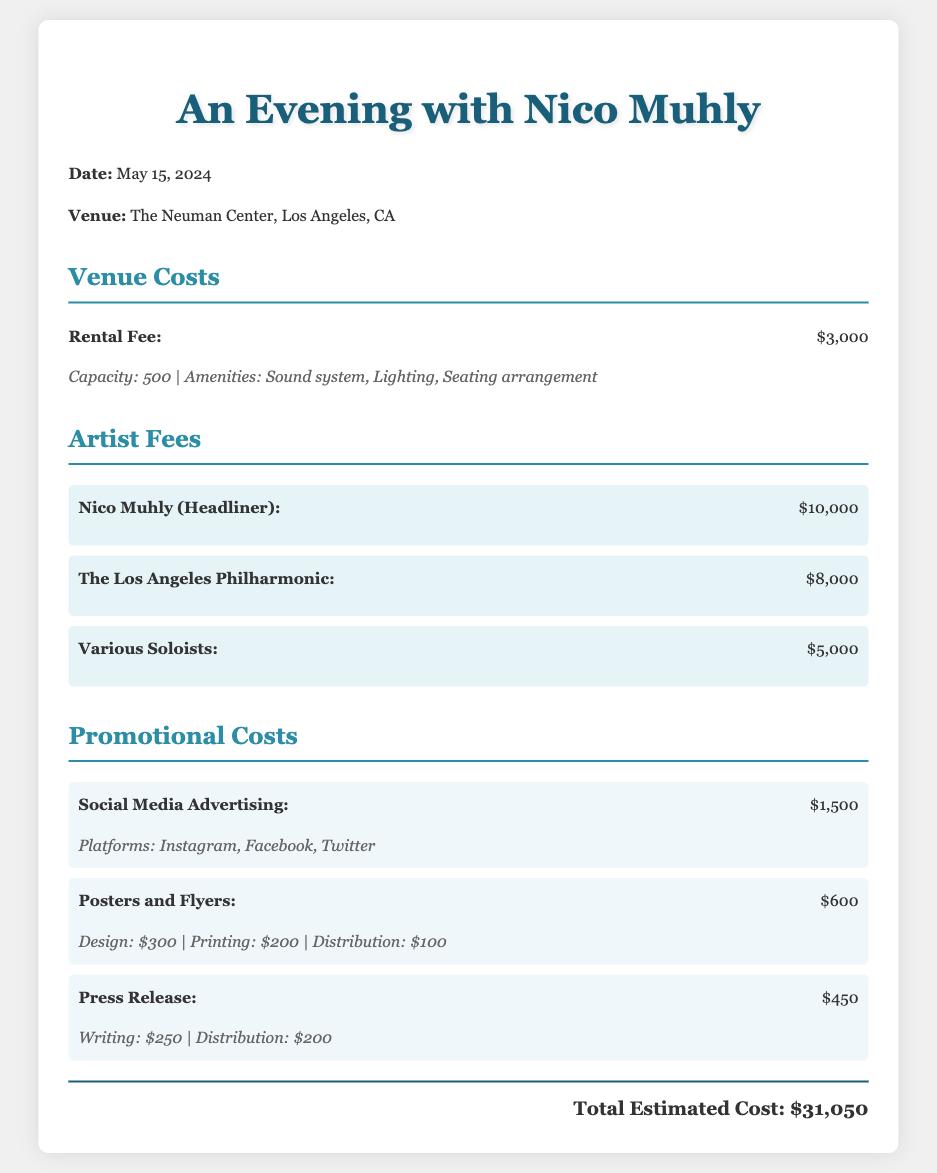What is the date of the concert? The date of the concert is specified in the document, which is May 15, 2024.
Answer: May 15, 2024 What is the total estimated cost? The total estimated cost is stated in the document, which sums up all the expenses listed.
Answer: $31,050 What is the rental fee for the venue? The rental fee for the venue is explicitly mentioned in the budget section as $3,000.
Answer: $3,000 How much is Nico Muhly's artist fee? The artist fee for Nico Muhly is listed as the headliner fee in the document, which is $10,000.
Answer: $10,000 What is the cost for social media advertising? The cost for social media advertising is specifically indicated in the document as $1,500.
Answer: $1,500 How much do the various soloists cost? The cost for various soloists is detailed in the artist fees section, stated as $5,000.
Answer: $5,000 Which platforms are included in the social media advertising? The platforms used for advertising are mentioned in the promotional costs section of the document.
Answer: Instagram, Facebook, Twitter What is the fee for the Los Angeles Philharmonic? The fee for the Los Angeles Philharmonic is explicitly stated in the document, which is $8,000.
Answer: $8,000 